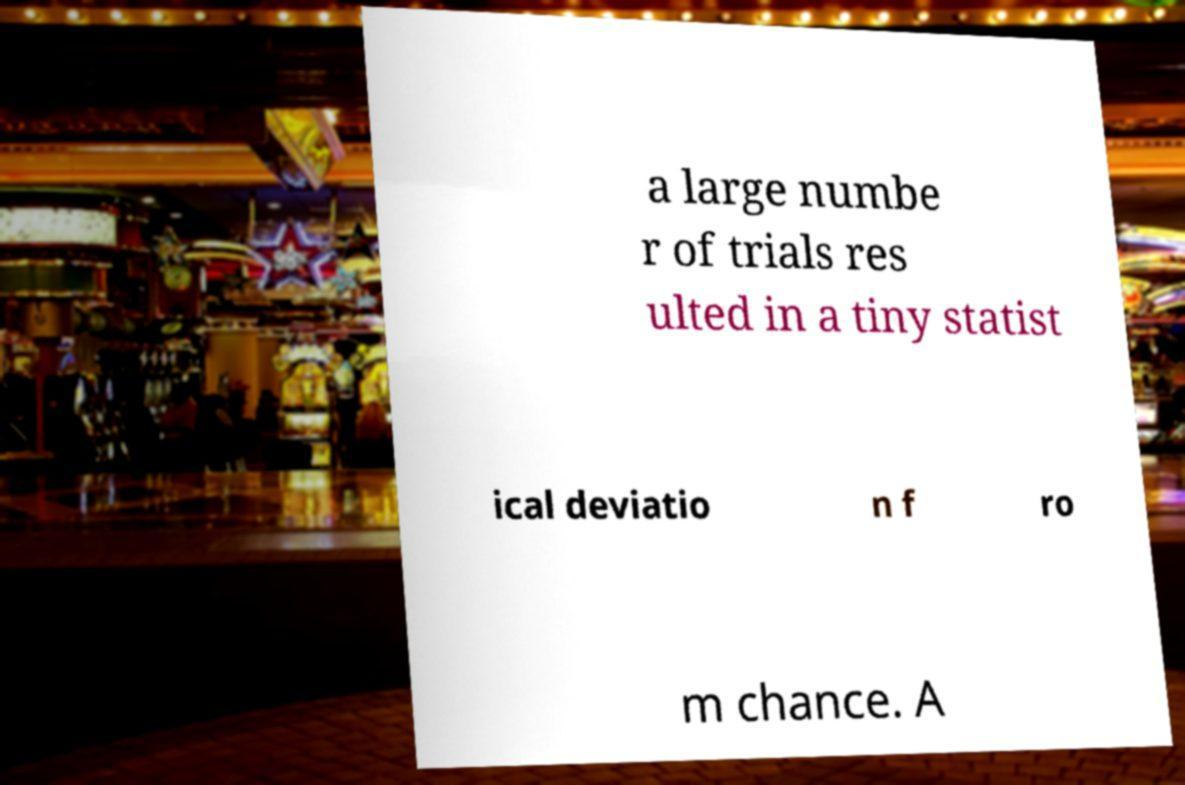Please read and relay the text visible in this image. What does it say? a large numbe r of trials res ulted in a tiny statist ical deviatio n f ro m chance. A 